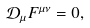Convert formula to latex. <formula><loc_0><loc_0><loc_500><loc_500>\mathcal { D } _ { \mu } F ^ { \mu \nu } = 0 ,</formula> 